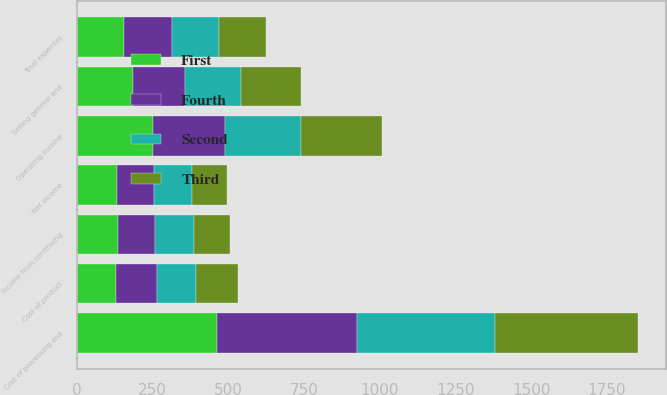Convert chart. <chart><loc_0><loc_0><loc_500><loc_500><stacked_bar_chart><ecel><fcel>Cost of processing and<fcel>Cost of product<fcel>Selling general and<fcel>Total expenses<fcel>Operating income<fcel>Income from continuing<fcel>Net income<nl><fcel>Fourth<fcel>462<fcel>136<fcel>172<fcel>156<fcel>238<fcel>123<fcel>121<nl><fcel>Second<fcel>457<fcel>129<fcel>185<fcel>156<fcel>251<fcel>130<fcel>127<nl><fcel>First<fcel>461<fcel>128<fcel>185<fcel>156<fcel>251<fcel>134<fcel>132<nl><fcel>Third<fcel>473<fcel>140<fcel>198<fcel>156<fcel>267<fcel>119<fcel>116<nl></chart> 